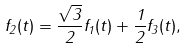Convert formula to latex. <formula><loc_0><loc_0><loc_500><loc_500>f _ { 2 } ( t ) = \frac { \sqrt { 3 } } { 2 } f _ { 1 } ( t ) + \frac { 1 } { 2 } f _ { 3 } ( t ) ,</formula> 